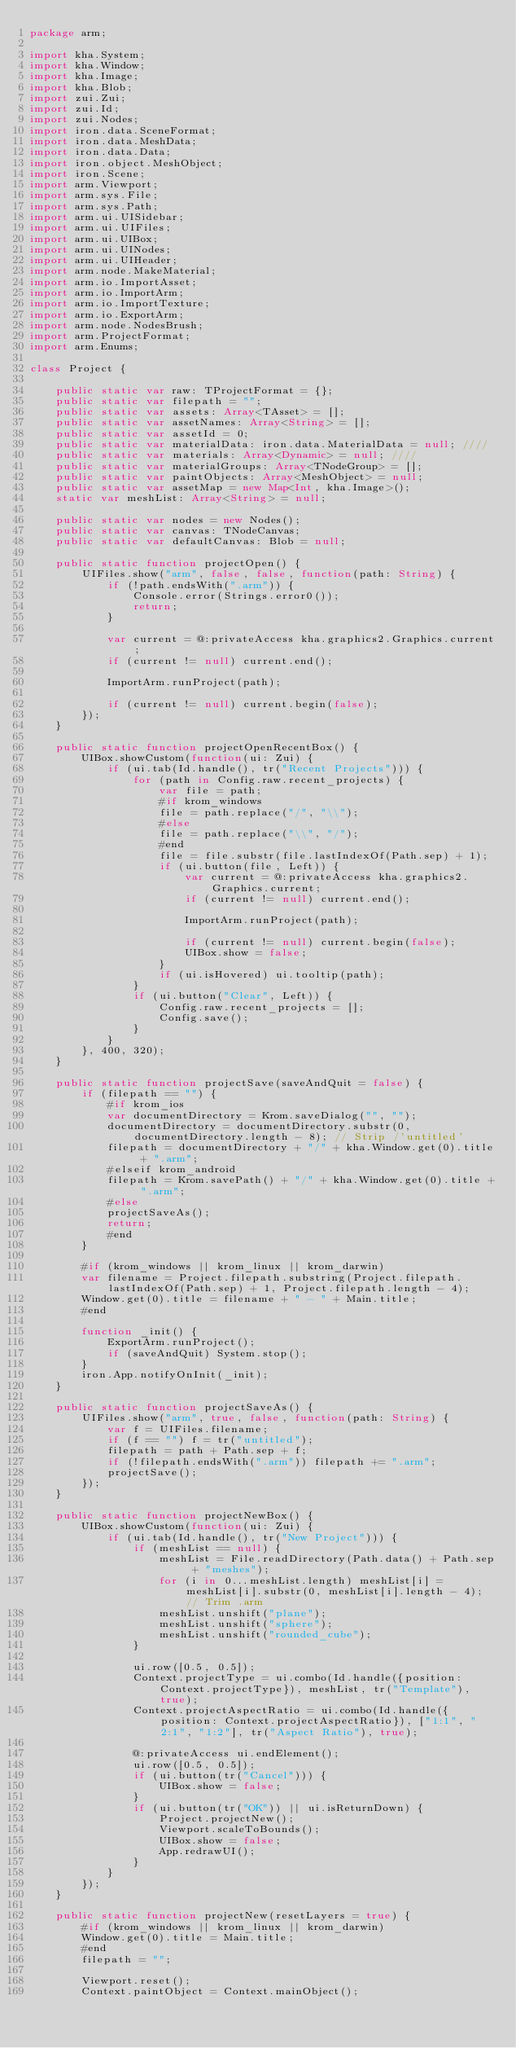Convert code to text. <code><loc_0><loc_0><loc_500><loc_500><_Haxe_>package arm;

import kha.System;
import kha.Window;
import kha.Image;
import kha.Blob;
import zui.Zui;
import zui.Id;
import zui.Nodes;
import iron.data.SceneFormat;
import iron.data.MeshData;
import iron.data.Data;
import iron.object.MeshObject;
import iron.Scene;
import arm.Viewport;
import arm.sys.File;
import arm.sys.Path;
import arm.ui.UISidebar;
import arm.ui.UIFiles;
import arm.ui.UIBox;
import arm.ui.UINodes;
import arm.ui.UIHeader;
import arm.node.MakeMaterial;
import arm.io.ImportAsset;
import arm.io.ImportArm;
import arm.io.ImportTexture;
import arm.io.ExportArm;
import arm.node.NodesBrush;
import arm.ProjectFormat;
import arm.Enums;

class Project {

	public static var raw: TProjectFormat = {};
	public static var filepath = "";
	public static var assets: Array<TAsset> = [];
	public static var assetNames: Array<String> = [];
	public static var assetId = 0;
	public static var materialData: iron.data.MaterialData = null; ////
	public static var materials: Array<Dynamic> = null; ////
	public static var materialGroups: Array<TNodeGroup> = [];
	public static var paintObjects: Array<MeshObject> = null;
	public static var assetMap = new Map<Int, kha.Image>();
	static var meshList: Array<String> = null;

	public static var nodes = new Nodes();
	public static var canvas: TNodeCanvas;
	public static var defaultCanvas: Blob = null;

	public static function projectOpen() {
		UIFiles.show("arm", false, false, function(path: String) {
			if (!path.endsWith(".arm")) {
				Console.error(Strings.error0());
				return;
			}

			var current = @:privateAccess kha.graphics2.Graphics.current;
			if (current != null) current.end();

			ImportArm.runProject(path);

			if (current != null) current.begin(false);
		});
	}

	public static function projectOpenRecentBox() {
		UIBox.showCustom(function(ui: Zui) {
			if (ui.tab(Id.handle(), tr("Recent Projects"))) {
				for (path in Config.raw.recent_projects) {
					var file = path;
					#if krom_windows
					file = path.replace("/", "\\");
					#else
					file = path.replace("\\", "/");
					#end
					file = file.substr(file.lastIndexOf(Path.sep) + 1);
					if (ui.button(file, Left)) {
						var current = @:privateAccess kha.graphics2.Graphics.current;
						if (current != null) current.end();

						ImportArm.runProject(path);

						if (current != null) current.begin(false);
						UIBox.show = false;
					}
					if (ui.isHovered) ui.tooltip(path);
				}
				if (ui.button("Clear", Left)) {
					Config.raw.recent_projects = [];
					Config.save();
				}
			}
		}, 400, 320);
	}

	public static function projectSave(saveAndQuit = false) {
		if (filepath == "") {
			#if krom_ios
			var documentDirectory = Krom.saveDialog("", "");
			documentDirectory = documentDirectory.substr(0, documentDirectory.length - 8); // Strip /'untitled'
			filepath = documentDirectory + "/" + kha.Window.get(0).title + ".arm";
			#elseif krom_android
			filepath = Krom.savePath() + "/" + kha.Window.get(0).title + ".arm";
			#else
			projectSaveAs();
			return;
			#end
		}

		#if (krom_windows || krom_linux || krom_darwin)
		var filename = Project.filepath.substring(Project.filepath.lastIndexOf(Path.sep) + 1, Project.filepath.length - 4);
		Window.get(0).title = filename + " - " + Main.title;
		#end

		function _init() {
			ExportArm.runProject();
			if (saveAndQuit) System.stop();
		}
		iron.App.notifyOnInit(_init);
	}

	public static function projectSaveAs() {
		UIFiles.show("arm", true, false, function(path: String) {
			var f = UIFiles.filename;
			if (f == "") f = tr("untitled");
			filepath = path + Path.sep + f;
			if (!filepath.endsWith(".arm")) filepath += ".arm";
			projectSave();
		});
	}

	public static function projectNewBox() {
		UIBox.showCustom(function(ui: Zui) {
			if (ui.tab(Id.handle(), tr("New Project"))) {
				if (meshList == null) {
					meshList = File.readDirectory(Path.data() + Path.sep + "meshes");
					for (i in 0...meshList.length) meshList[i] = meshList[i].substr(0, meshList[i].length - 4); // Trim .arm
					meshList.unshift("plane");
					meshList.unshift("sphere");
					meshList.unshift("rounded_cube");
				}

				ui.row([0.5, 0.5]);
				Context.projectType = ui.combo(Id.handle({position: Context.projectType}), meshList, tr("Template"), true);
				Context.projectAspectRatio = ui.combo(Id.handle({position: Context.projectAspectRatio}), ["1:1", "2:1", "1:2"], tr("Aspect Ratio"), true);

				@:privateAccess ui.endElement();
				ui.row([0.5, 0.5]);
				if (ui.button(tr("Cancel"))) {
					UIBox.show = false;
				}
				if (ui.button(tr("OK")) || ui.isReturnDown) {
					Project.projectNew();
					Viewport.scaleToBounds();
					UIBox.show = false;
					App.redrawUI();
				}
			}
		});
	}

	public static function projectNew(resetLayers = true) {
		#if (krom_windows || krom_linux || krom_darwin)
		Window.get(0).title = Main.title;
		#end
		filepath = "";

		Viewport.reset();
		Context.paintObject = Context.mainObject();
</code> 